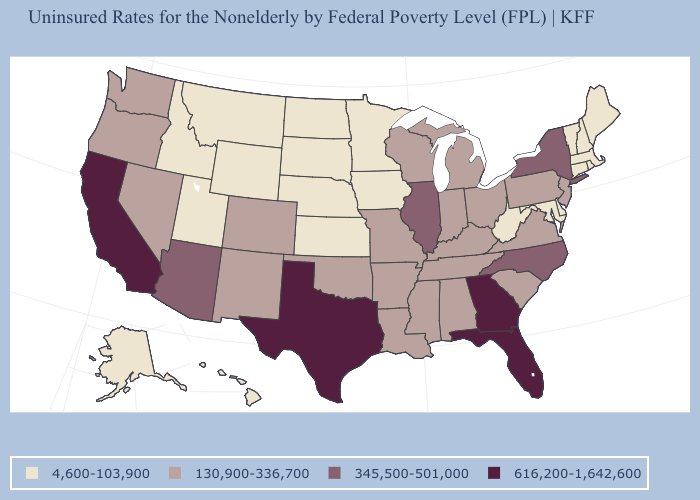What is the value of West Virginia?
Write a very short answer. 4,600-103,900. Does Arizona have the highest value in the USA?
Keep it brief. No. What is the value of Delaware?
Be succinct. 4,600-103,900. What is the value of New Hampshire?
Short answer required. 4,600-103,900. Is the legend a continuous bar?
Concise answer only. No. Which states have the lowest value in the West?
Concise answer only. Alaska, Hawaii, Idaho, Montana, Utah, Wyoming. What is the highest value in the MidWest ?
Quick response, please. 345,500-501,000. What is the value of Hawaii?
Concise answer only. 4,600-103,900. Does Indiana have a higher value than New Jersey?
Keep it brief. No. What is the highest value in states that border Wisconsin?
Keep it brief. 345,500-501,000. What is the value of North Carolina?
Give a very brief answer. 345,500-501,000. Name the states that have a value in the range 4,600-103,900?
Short answer required. Alaska, Connecticut, Delaware, Hawaii, Idaho, Iowa, Kansas, Maine, Maryland, Massachusetts, Minnesota, Montana, Nebraska, New Hampshire, North Dakota, Rhode Island, South Dakota, Utah, Vermont, West Virginia, Wyoming. Name the states that have a value in the range 616,200-1,642,600?
Write a very short answer. California, Florida, Georgia, Texas. Name the states that have a value in the range 345,500-501,000?
Short answer required. Arizona, Illinois, New York, North Carolina. 